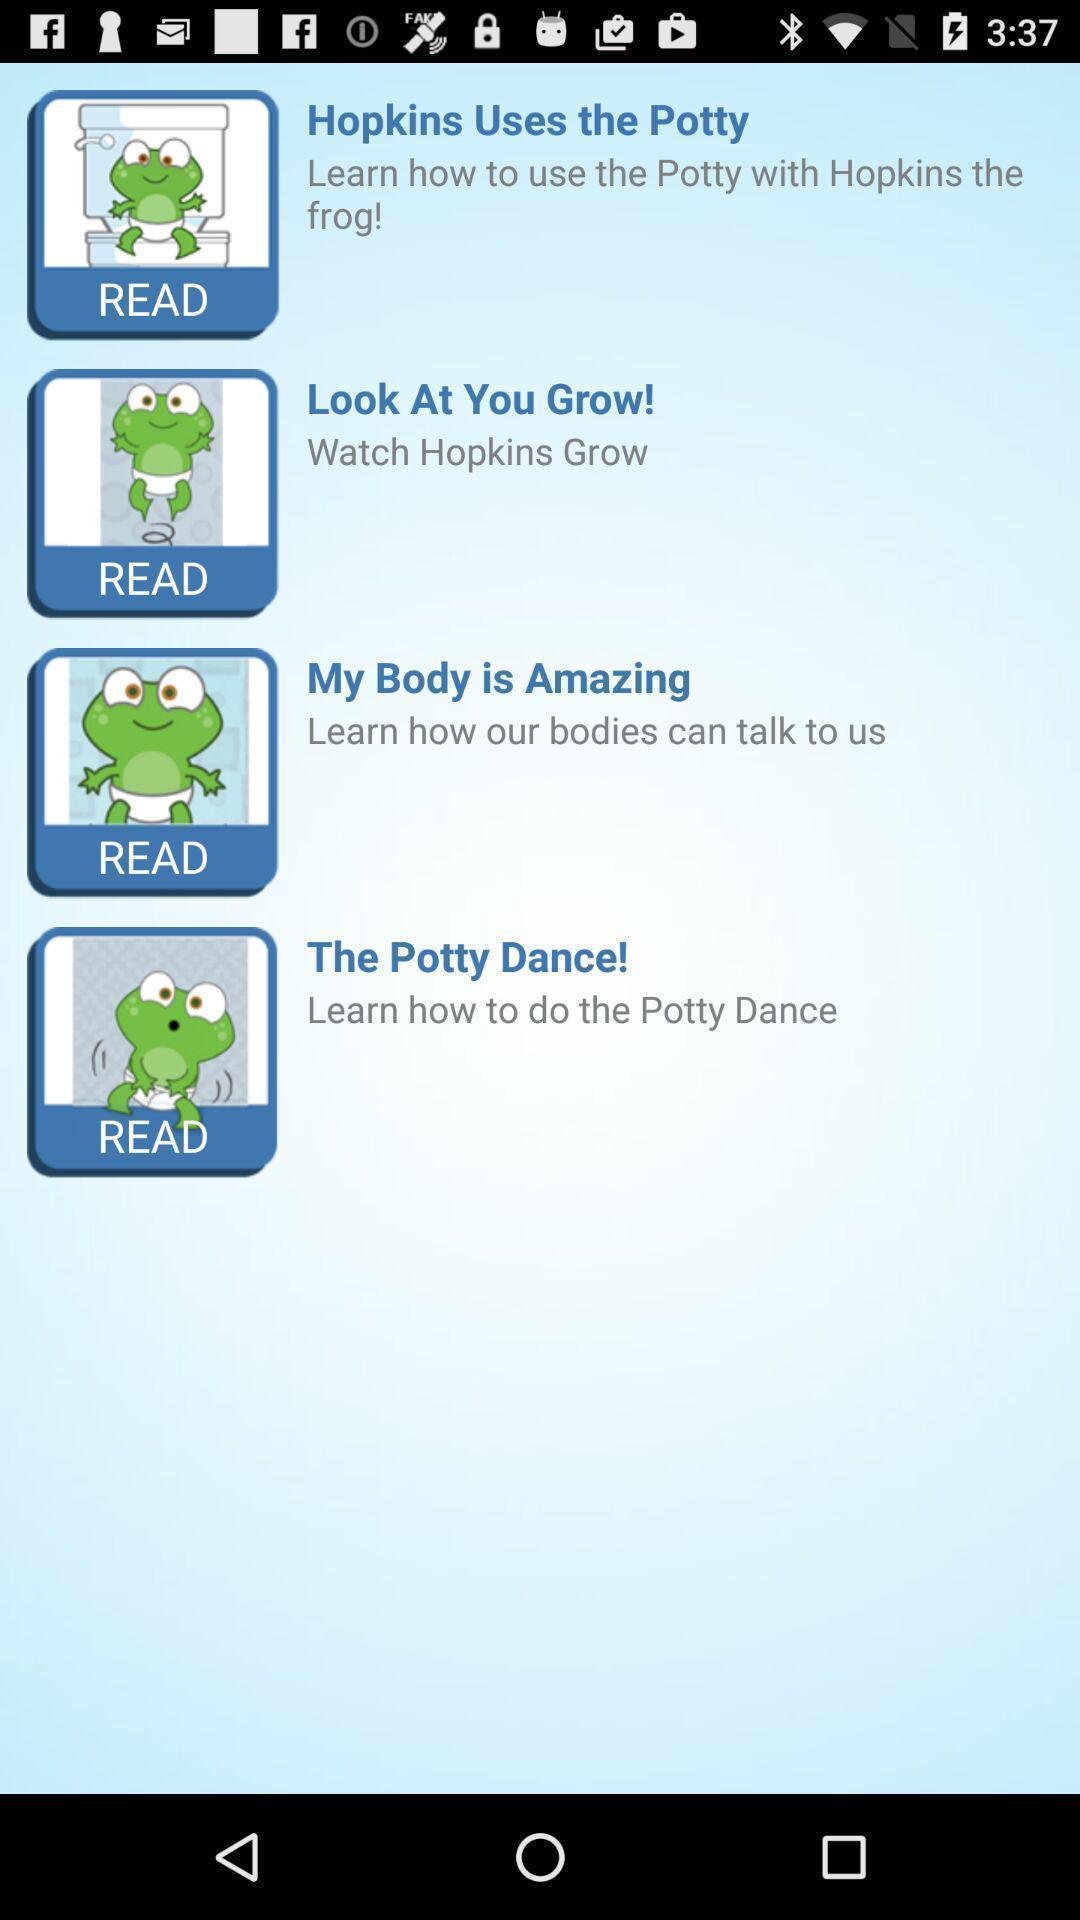Please provide a description for this image. Screen displaying multiple stickers with names. 